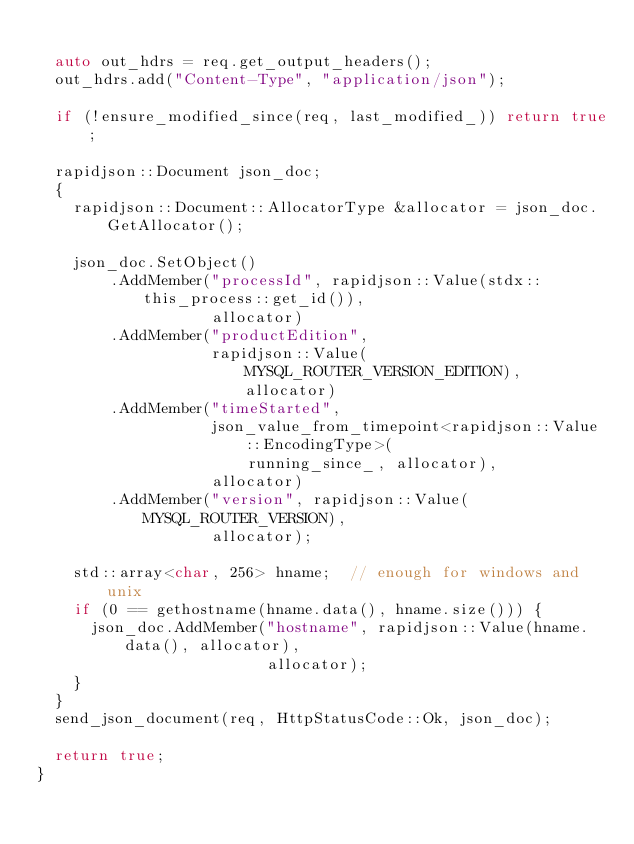<code> <loc_0><loc_0><loc_500><loc_500><_C++_>
  auto out_hdrs = req.get_output_headers();
  out_hdrs.add("Content-Type", "application/json");

  if (!ensure_modified_since(req, last_modified_)) return true;

  rapidjson::Document json_doc;
  {
    rapidjson::Document::AllocatorType &allocator = json_doc.GetAllocator();

    json_doc.SetObject()
        .AddMember("processId", rapidjson::Value(stdx::this_process::get_id()),
                   allocator)
        .AddMember("productEdition",
                   rapidjson::Value(MYSQL_ROUTER_VERSION_EDITION), allocator)
        .AddMember("timeStarted",
                   json_value_from_timepoint<rapidjson::Value::EncodingType>(
                       running_since_, allocator),
                   allocator)
        .AddMember("version", rapidjson::Value(MYSQL_ROUTER_VERSION),
                   allocator);

    std::array<char, 256> hname;  // enough for windows and unix
    if (0 == gethostname(hname.data(), hname.size())) {
      json_doc.AddMember("hostname", rapidjson::Value(hname.data(), allocator),
                         allocator);
    }
  }
  send_json_document(req, HttpStatusCode::Ok, json_doc);

  return true;
}
</code> 